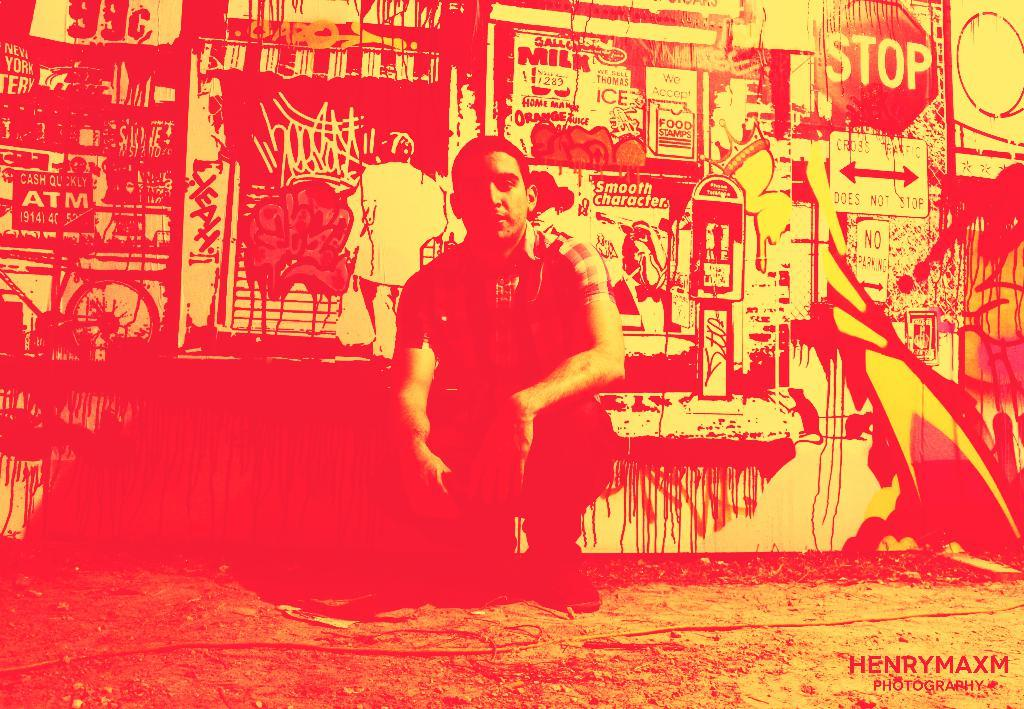<image>
Describe the image concisely. A young man crouches down in front of a wall with graffiti and a stop sign to his left. 